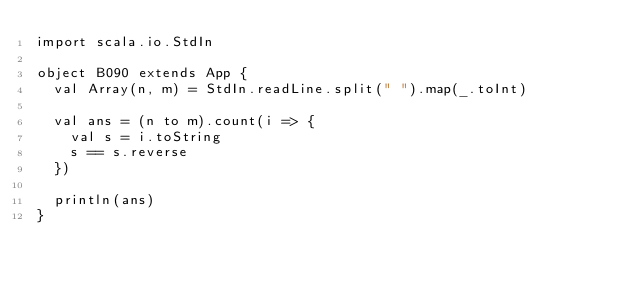<code> <loc_0><loc_0><loc_500><loc_500><_Scala_>import scala.io.StdIn

object B090 extends App {
  val Array(n, m) = StdIn.readLine.split(" ").map(_.toInt)

  val ans = (n to m).count(i => {
    val s = i.toString
    s == s.reverse
  })

  println(ans)
}
</code> 